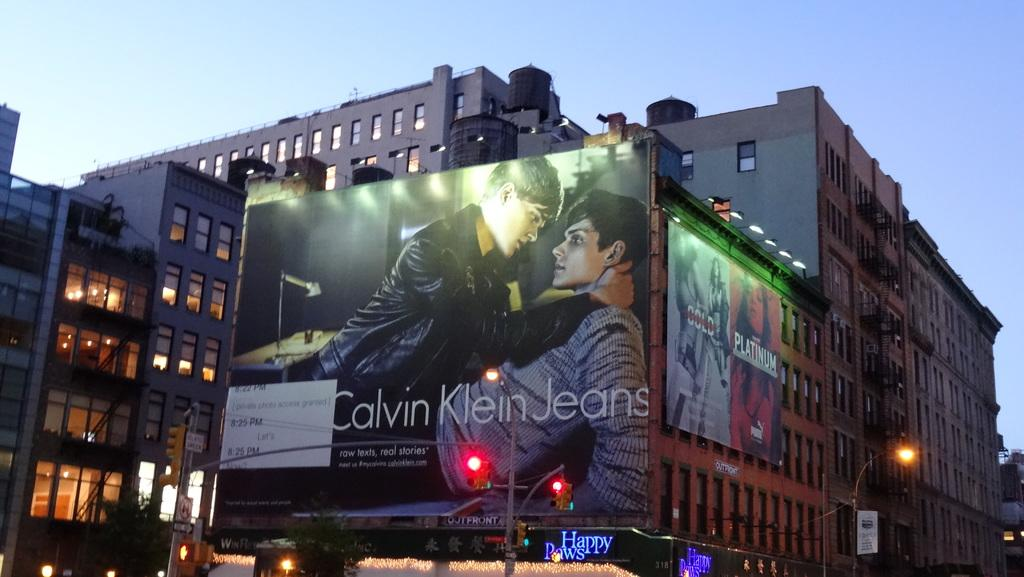<image>
Relay a brief, clear account of the picture shown. A large billboard for Calvin Klein Jeans lit up on a city street. 